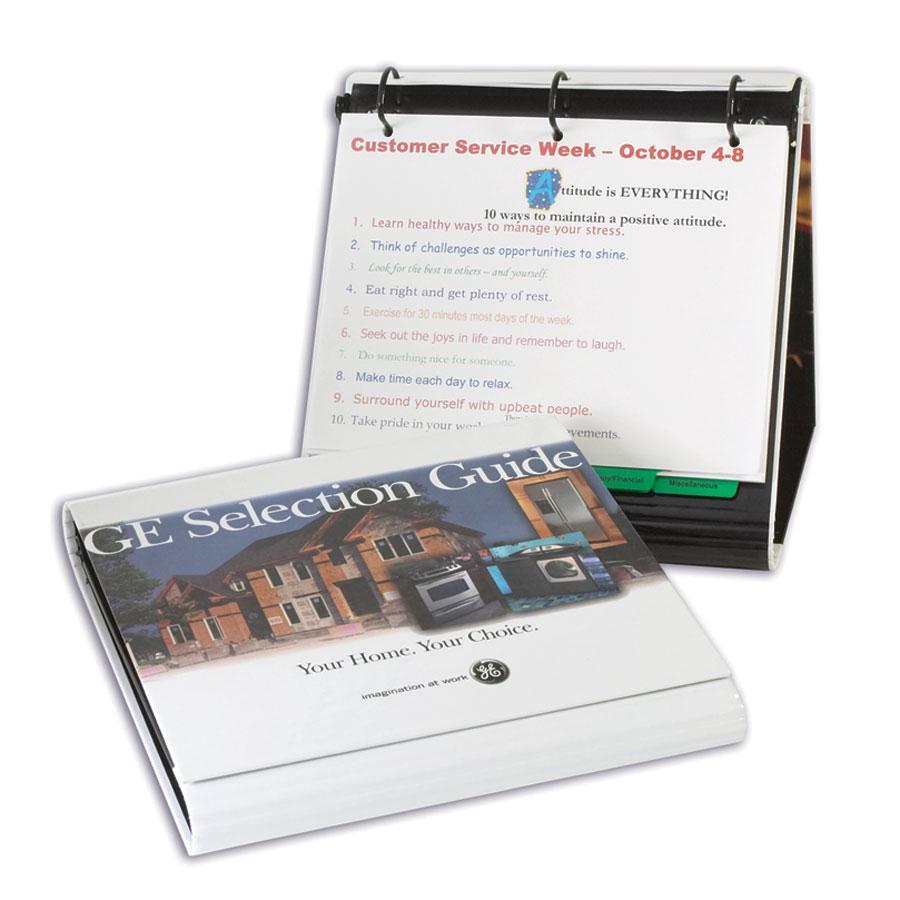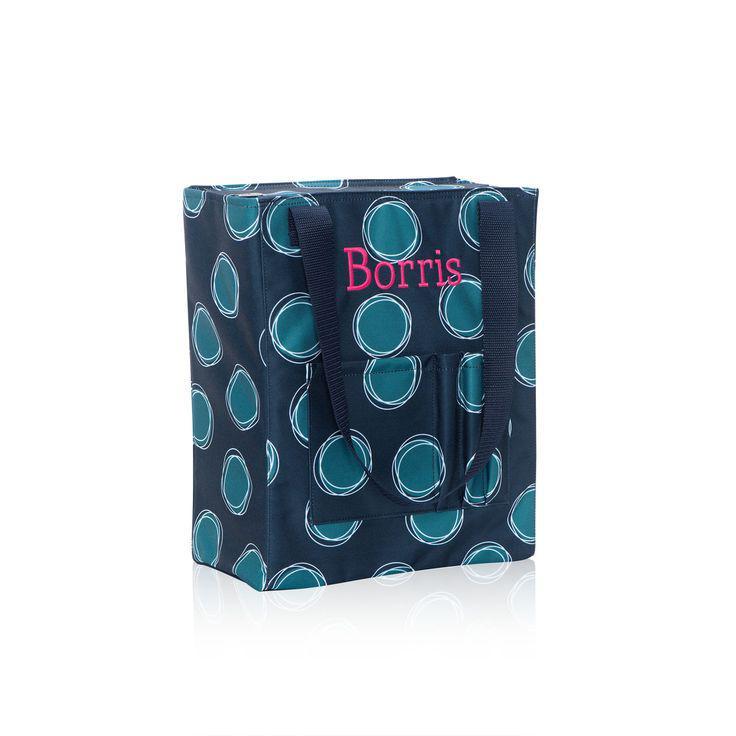The first image is the image on the left, the second image is the image on the right. Given the left and right images, does the statement "There are writing utensils inside a mesh compartment." hold true? Answer yes or no. No. The first image is the image on the left, the second image is the image on the right. Examine the images to the left and right. Is the description "Each image includes one open ring binder, and at least one of the binders pictured is filled with paper and other supplies." accurate? Answer yes or no. No. 